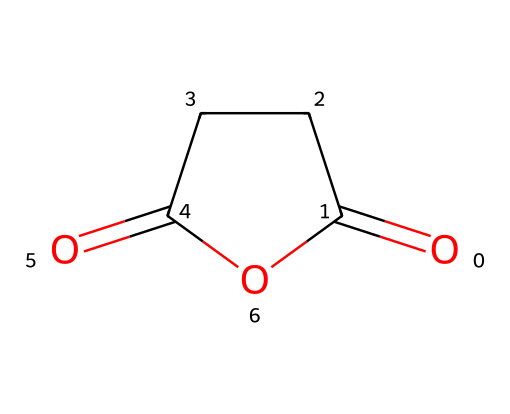how many carbon atoms are in succinic anhydride? By inspecting the SMILES representation, we can identify that there are four carbon atoms (C) present in the cyclic structure. Each 'C' in the SMILES corresponds to a carbon atom.
Answer: four what is the functional group present in succinic anhydride? The presence of the anhydride functional group is indicated by the connection between the two carbonyl (C=O) groups and a ring structure. This is characteristic of acid anhydrides.
Answer: anhydride how many oxygen atoms are in succinic anhydride? The SMILES structure reveals that there are two oxygen atoms indicated by the 'O' letters.
Answer: two what shape does the structure of succinic anhydride suggest? The cyclic structure with the anhydride group suggests a ring shape. This is evident from the way the carbon atoms and oxygen atoms are connected to form a closed loop.
Answer: ring how many double bonds are present in succinic anhydride? Analyzing the SMILES, we see that there are two double bonds (C=O) in the structure, one associated with each carbonyl oxygen.
Answer: two what type of compound is succinic anhydride classified as? This compound is classified as an acid anhydride, which is derived from the condensation of carboxylic acids. This classification stems from its structural features as indicated in the SMILES notation.
Answer: acid anhydride 